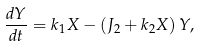<formula> <loc_0><loc_0><loc_500><loc_500>\frac { d Y } { d t } = k _ { 1 } X - \left ( J _ { 2 } + k _ { 2 } X \right ) Y ,</formula> 